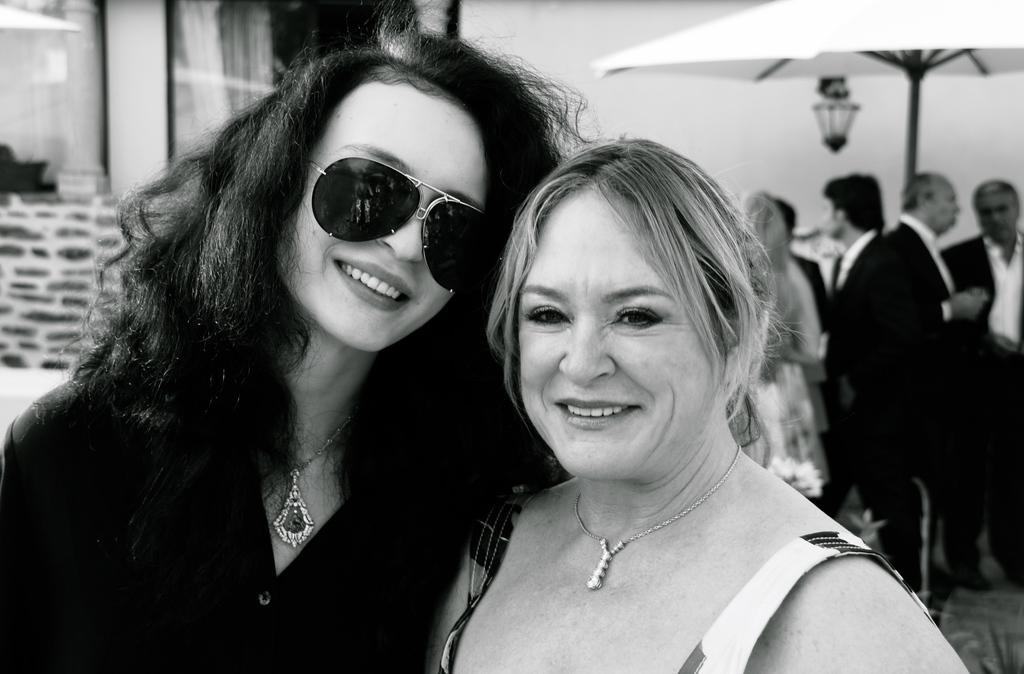What is the color scheme of the image? The image is black and white. How many women are standing in the image? There are 2 women standing in the image. What is the woman on the left wearing? The woman on the left is wearing goggles. What object can be seen in the image that provides shade or protection from the rain? There is an umbrella visible in the image. What object in the image provides light? There is a lamp in the image. Can you describe the people in the background of the image? There are other people standing in the background of the image. How many wheels are visible on the women in the image? There are no wheels visible on the women in the image. What type of step is the woman on the right taking in the image? There is no indication of the woman on the right taking a step in the image. 